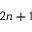Convert formula to latex. <formula><loc_0><loc_0><loc_500><loc_500>2 n + 1</formula> 